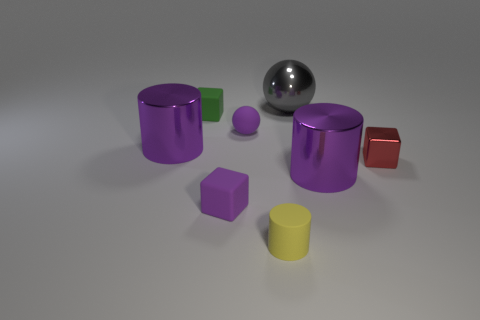There is a gray object that is the same material as the red thing; what is its size?
Your answer should be very brief. Large. The yellow cylinder has what size?
Ensure brevity in your answer.  Small. Is the material of the big gray thing the same as the tiny purple ball?
Your answer should be compact. No. How many cylinders are either big metal things or purple shiny objects?
Your response must be concise. 2. There is a small matte block that is in front of the metallic object to the left of the yellow rubber cylinder; what is its color?
Your response must be concise. Purple. There is a purple matte object behind the large object that is to the left of the green rubber cube; what number of tiny purple rubber things are right of it?
Make the answer very short. 0. There is a shiny thing that is behind the green thing; is its shape the same as the tiny purple thing that is behind the red metallic object?
Your response must be concise. Yes. How many things are green blocks or purple spheres?
Offer a very short reply. 2. There is a thing to the right of the metallic cylinder right of the small yellow cylinder; what is it made of?
Offer a terse response. Metal. Is there a thing of the same color as the rubber sphere?
Keep it short and to the point. Yes. 